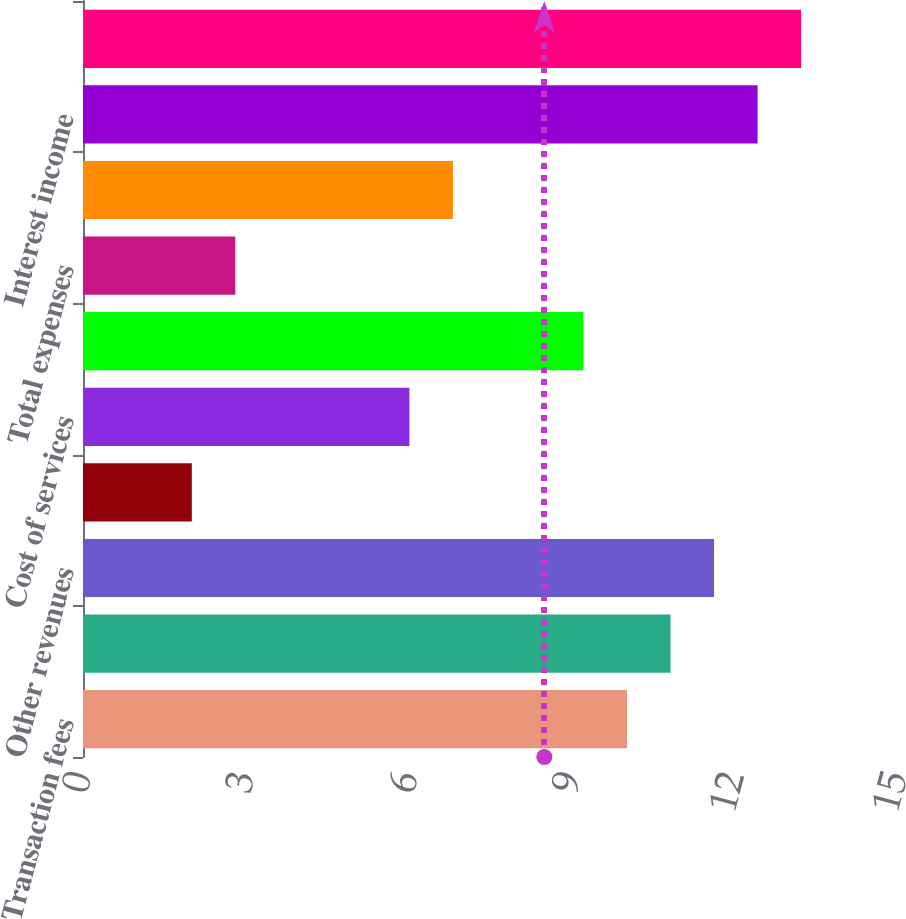<chart> <loc_0><loc_0><loc_500><loc_500><bar_chart><fcel>Transaction fees<fcel>Foreign exchange revenues<fcel>Other revenues<fcel>Total revenues<fcel>Cost of services<fcel>Selling general and<fcel>Total expenses<fcel>Operating income<fcel>Interest income<fcel>Interest expense<nl><fcel>10<fcel>10.8<fcel>11.6<fcel>2<fcel>6<fcel>9.2<fcel>2.8<fcel>6.8<fcel>12.4<fcel>13.2<nl></chart> 